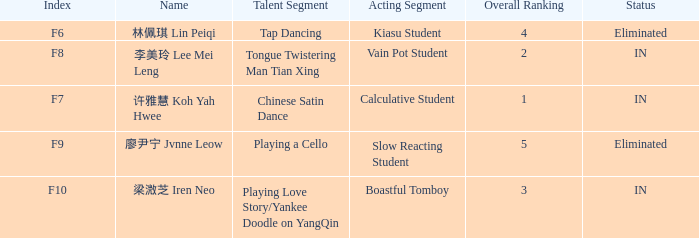What's the acting segment of 林佩琪 lin peiqi's events that are eliminated? Kiasu Student. 